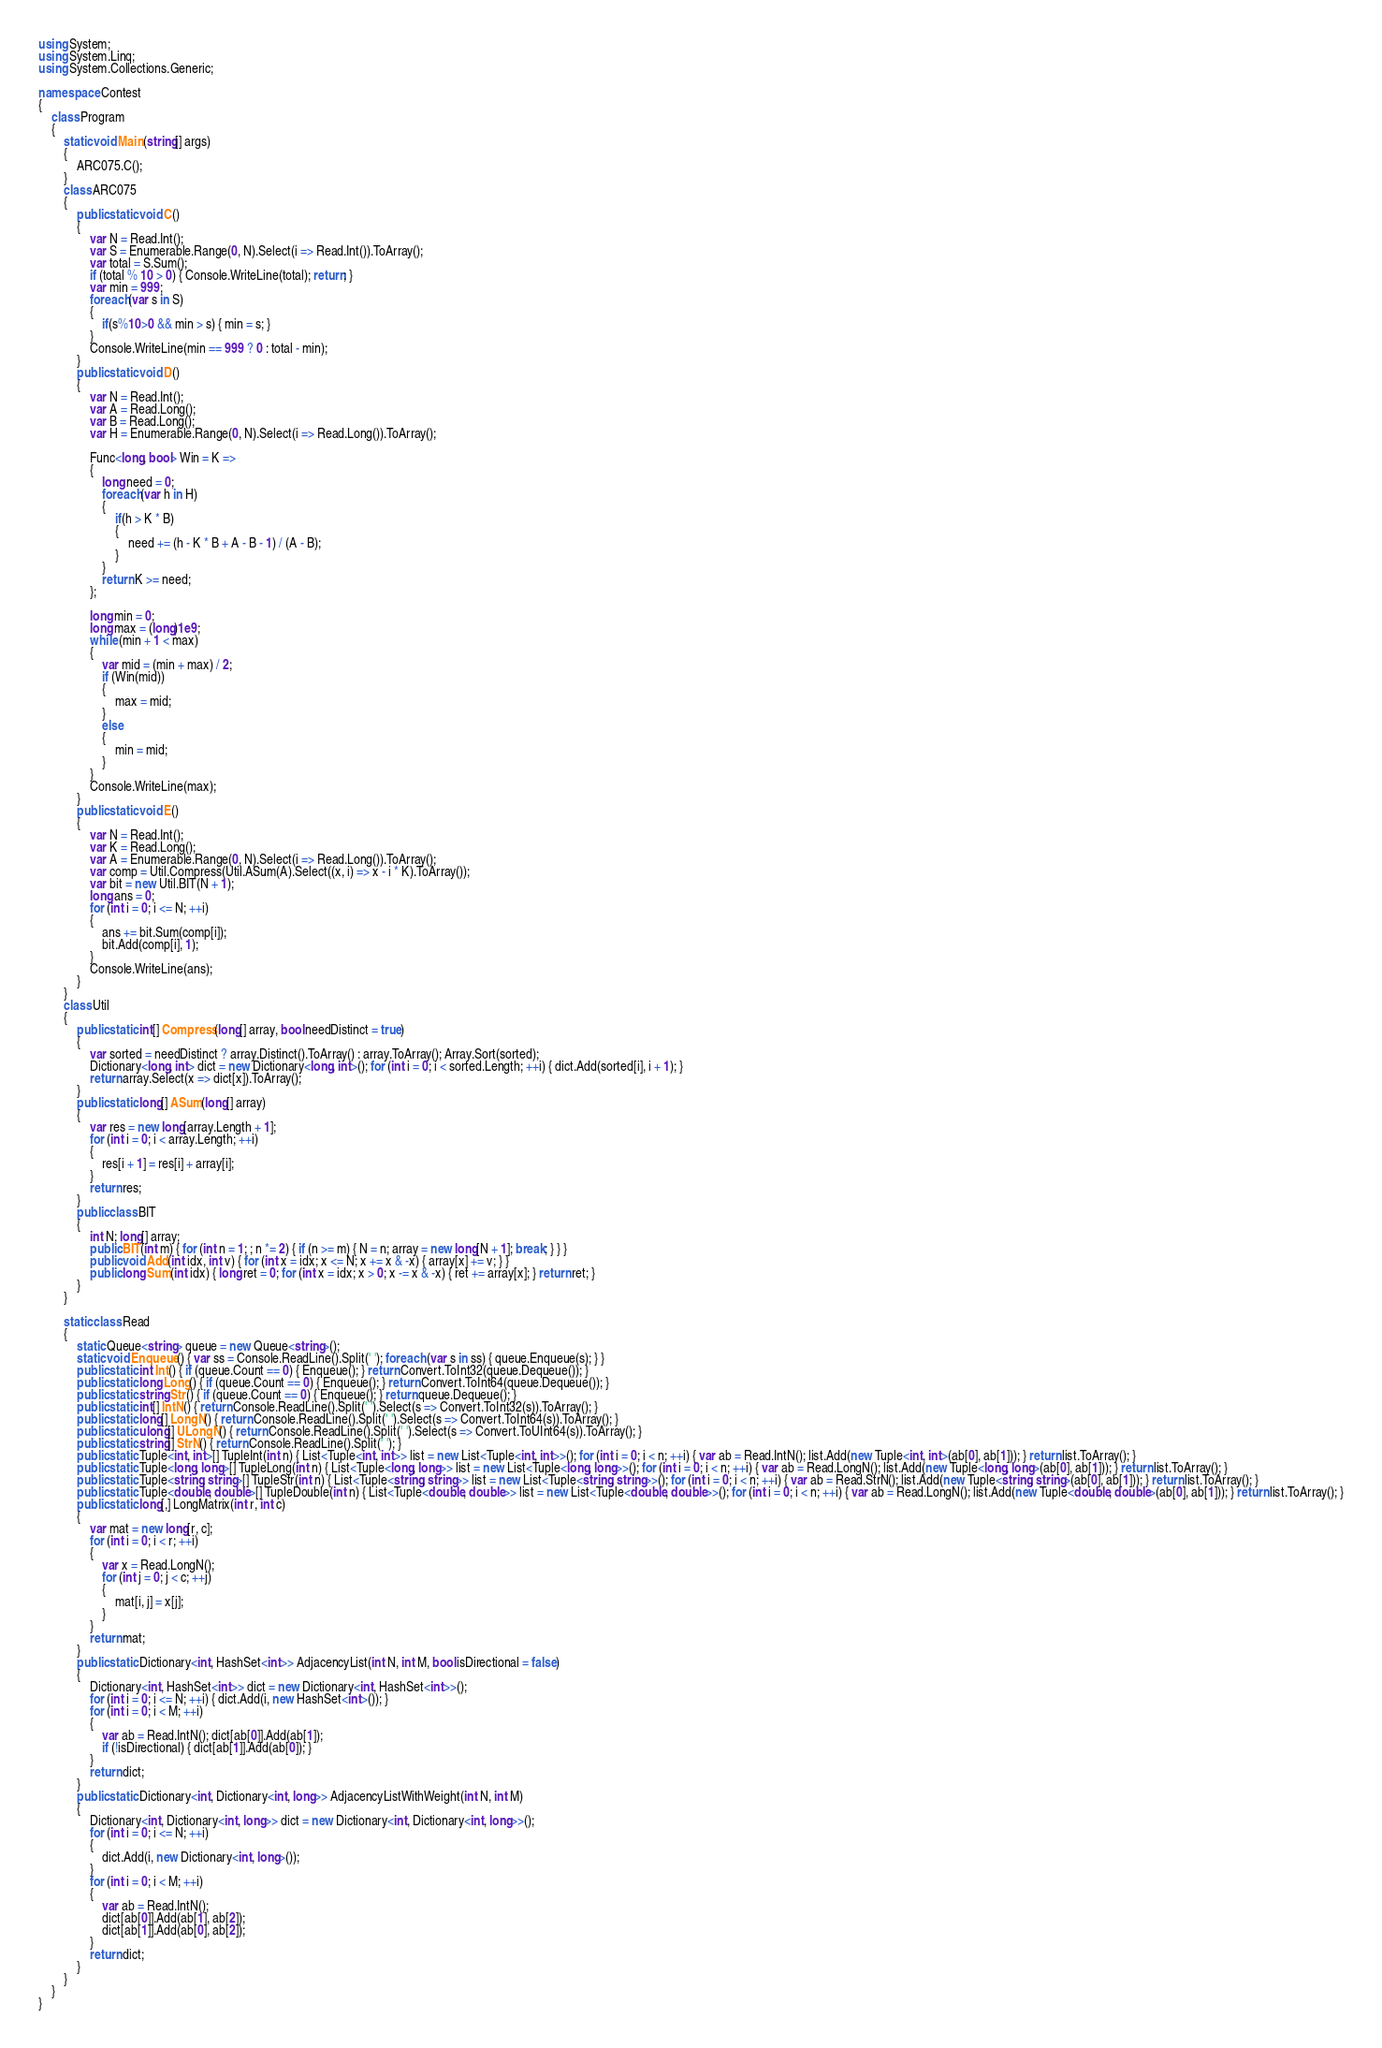<code> <loc_0><loc_0><loc_500><loc_500><_C#_>using System;
using System.Linq;
using System.Collections.Generic;

namespace Contest
{
    class Program
    {
        static void Main(string[] args)
        {
            ARC075.C();
        }
        class ARC075
        {
            public static void C()
            {
                var N = Read.Int();
                var S = Enumerable.Range(0, N).Select(i => Read.Int()).ToArray();
                var total = S.Sum();
                if (total % 10 > 0) { Console.WriteLine(total); return; }
                var min = 999;
                foreach(var s in S)
                {
                    if(s%10>0 && min > s) { min = s; }
                }
                Console.WriteLine(min == 999 ? 0 : total - min);
            }
            public static void D()
            {
                var N = Read.Int();
                var A = Read.Long();
                var B = Read.Long();
                var H = Enumerable.Range(0, N).Select(i => Read.Long()).ToArray();

                Func<long, bool> Win = K =>
                {
                    long need = 0;
                    foreach(var h in H)
                    {
                        if(h > K * B)
                        {
                            need += (h - K * B + A - B - 1) / (A - B);
                        }
                    }
                    return K >= need;
                };

                long min = 0;
                long max = (long)1e9;
                while (min + 1 < max)
                {
                    var mid = (min + max) / 2;
                    if (Win(mid))
                    {
                        max = mid;
                    }
                    else
                    {
                        min = mid;
                    }
                }
                Console.WriteLine(max);
            }
            public static void E()
            {
                var N = Read.Int();
                var K = Read.Long();
                var A = Enumerable.Range(0, N).Select(i => Read.Long()).ToArray();
                var comp = Util.Compress(Util.ASum(A).Select((x, i) => x - i * K).ToArray());
                var bit = new Util.BIT(N + 1);
                long ans = 0;
                for (int i = 0; i <= N; ++i)
                {
                    ans += bit.Sum(comp[i]);
                    bit.Add(comp[i], 1);
                }
                Console.WriteLine(ans);
            }
        }
        class Util
        {
            public static int[] Compress(long[] array, bool needDistinct = true)
            {
                var sorted = needDistinct ? array.Distinct().ToArray() : array.ToArray(); Array.Sort(sorted);
                Dictionary<long, int> dict = new Dictionary<long, int>(); for (int i = 0; i < sorted.Length; ++i) { dict.Add(sorted[i], i + 1); }
                return array.Select(x => dict[x]).ToArray();
            }
            public static long[] ASum(long[] array)
            {
                var res = new long[array.Length + 1];
                for (int i = 0; i < array.Length; ++i)
                {
                    res[i + 1] = res[i] + array[i];
                }
                return res;
            }
            public class BIT
            {
                int N; long[] array;
                public BIT(int m) { for (int n = 1; ; n *= 2) { if (n >= m) { N = n; array = new long[N + 1]; break; } } }
                public void Add(int idx, int v) { for (int x = idx; x <= N; x += x & -x) { array[x] += v; } }
                public long Sum(int idx) { long ret = 0; for (int x = idx; x > 0; x -= x & -x) { ret += array[x]; } return ret; }
            }
        }

        static class Read
        {
            static Queue<string> queue = new Queue<string>();
            static void Enqueue() { var ss = Console.ReadLine().Split(' '); foreach (var s in ss) { queue.Enqueue(s); } }
            public static int Int() { if (queue.Count == 0) { Enqueue(); } return Convert.ToInt32(queue.Dequeue()); }
            public static long Long() { if (queue.Count == 0) { Enqueue(); } return Convert.ToInt64(queue.Dequeue()); }
            public static string Str() { if (queue.Count == 0) { Enqueue(); } return queue.Dequeue(); }
            public static int[] IntN() { return Console.ReadLine().Split(' ').Select(s => Convert.ToInt32(s)).ToArray(); }
            public static long[] LongN() { return Console.ReadLine().Split(' ').Select(s => Convert.ToInt64(s)).ToArray(); }
            public static ulong[] ULongN() { return Console.ReadLine().Split(' ').Select(s => Convert.ToUInt64(s)).ToArray(); }
            public static string[] StrN() { return Console.ReadLine().Split(' '); }
            public static Tuple<int, int>[] TupleInt(int n) { List<Tuple<int, int>> list = new List<Tuple<int, int>>(); for (int i = 0; i < n; ++i) { var ab = Read.IntN(); list.Add(new Tuple<int, int>(ab[0], ab[1])); } return list.ToArray(); }
            public static Tuple<long, long>[] TupleLong(int n) { List<Tuple<long, long>> list = new List<Tuple<long, long>>(); for (int i = 0; i < n; ++i) { var ab = Read.LongN(); list.Add(new Tuple<long, long>(ab[0], ab[1])); } return list.ToArray(); }
            public static Tuple<string, string>[] TupleStr(int n) { List<Tuple<string, string>> list = new List<Tuple<string, string>>(); for (int i = 0; i < n; ++i) { var ab = Read.StrN(); list.Add(new Tuple<string, string>(ab[0], ab[1])); } return list.ToArray(); }
            public static Tuple<double, double>[] TupleDouble(int n) { List<Tuple<double, double>> list = new List<Tuple<double, double>>(); for (int i = 0; i < n; ++i) { var ab = Read.LongN(); list.Add(new Tuple<double, double>(ab[0], ab[1])); } return list.ToArray(); }
            public static long[,] LongMatrix(int r, int c)
            {
                var mat = new long[r, c];
                for (int i = 0; i < r; ++i)
                {
                    var x = Read.LongN();
                    for (int j = 0; j < c; ++j)
                    {
                        mat[i, j] = x[j];
                    }
                }
                return mat;
            }
            public static Dictionary<int, HashSet<int>> AdjacencyList(int N, int M, bool isDirectional = false)
            {
                Dictionary<int, HashSet<int>> dict = new Dictionary<int, HashSet<int>>();
                for (int i = 0; i <= N; ++i) { dict.Add(i, new HashSet<int>()); }
                for (int i = 0; i < M; ++i)
                {
                    var ab = Read.IntN(); dict[ab[0]].Add(ab[1]);
                    if (!isDirectional) { dict[ab[1]].Add(ab[0]); }
                }
                return dict;
            }
            public static Dictionary<int, Dictionary<int, long>> AdjacencyListWithWeight(int N, int M)
            {
                Dictionary<int, Dictionary<int, long>> dict = new Dictionary<int, Dictionary<int, long>>();
                for (int i = 0; i <= N; ++i)
                {
                    dict.Add(i, new Dictionary<int, long>());
                }
                for (int i = 0; i < M; ++i)
                {
                    var ab = Read.IntN();
                    dict[ab[0]].Add(ab[1], ab[2]);
                    dict[ab[1]].Add(ab[0], ab[2]);
                }
                return dict;
            }
        }
    }
}
</code> 